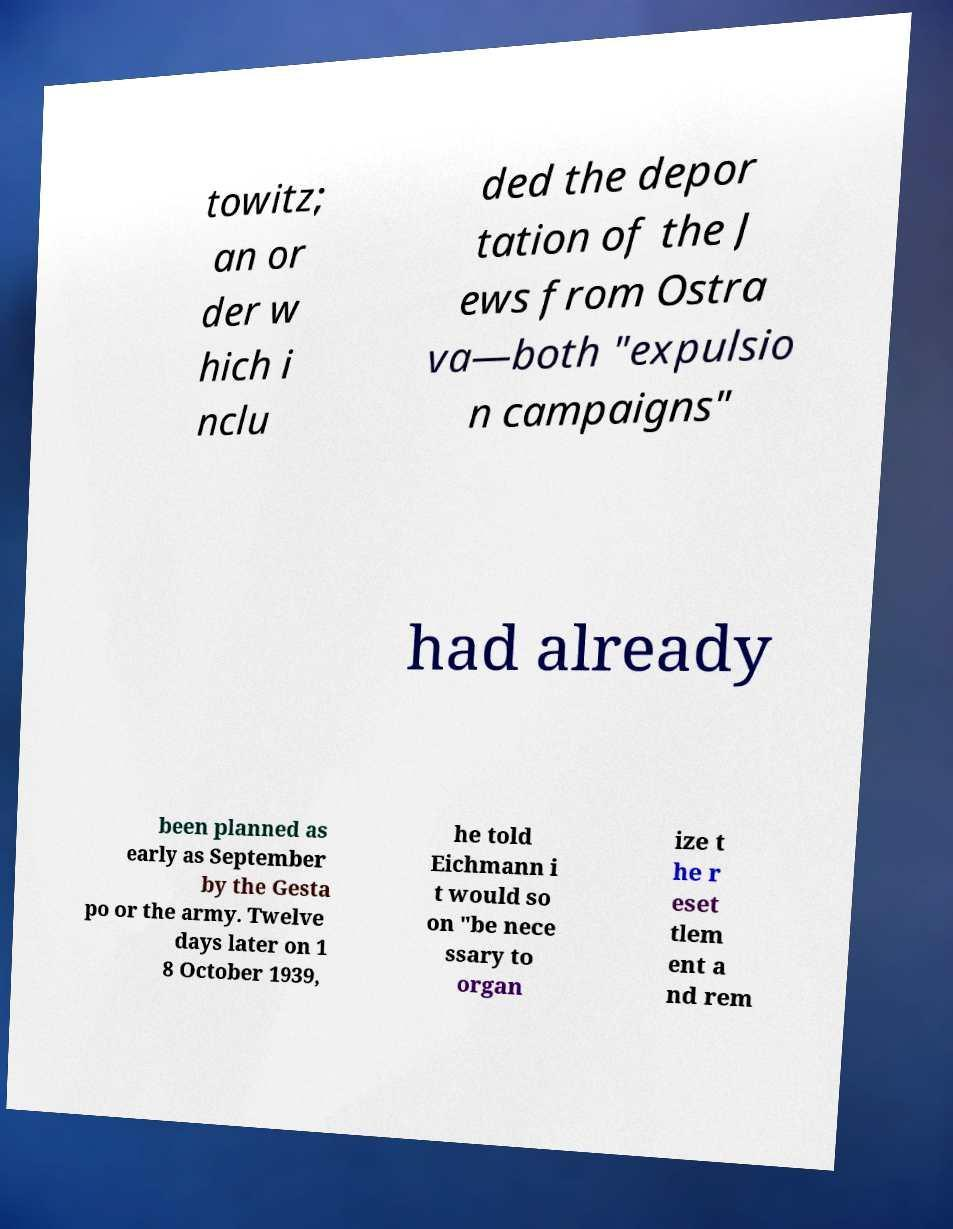Please read and relay the text visible in this image. What does it say? towitz; an or der w hich i nclu ded the depor tation of the J ews from Ostra va—both "expulsio n campaigns" had already been planned as early as September by the Gesta po or the army. Twelve days later on 1 8 October 1939, he told Eichmann i t would so on "be nece ssary to organ ize t he r eset tlem ent a nd rem 